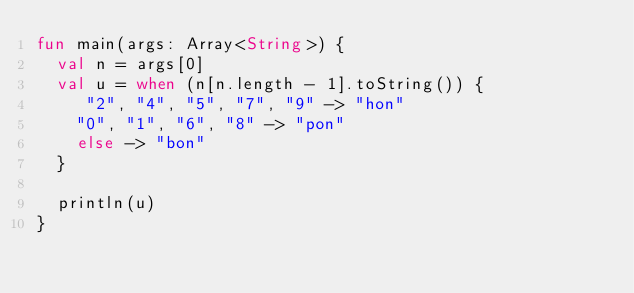Convert code to text. <code><loc_0><loc_0><loc_500><loc_500><_Kotlin_>fun main(args: Array<String>) {
  val n = args[0]
  val u = when (n[n.length - 1].toString()) {
     "2", "4", "5", "7", "9" -> "hon"
    "0", "1", "6", "8" -> "pon"
    else -> "bon"
  }

  println(u)
}</code> 